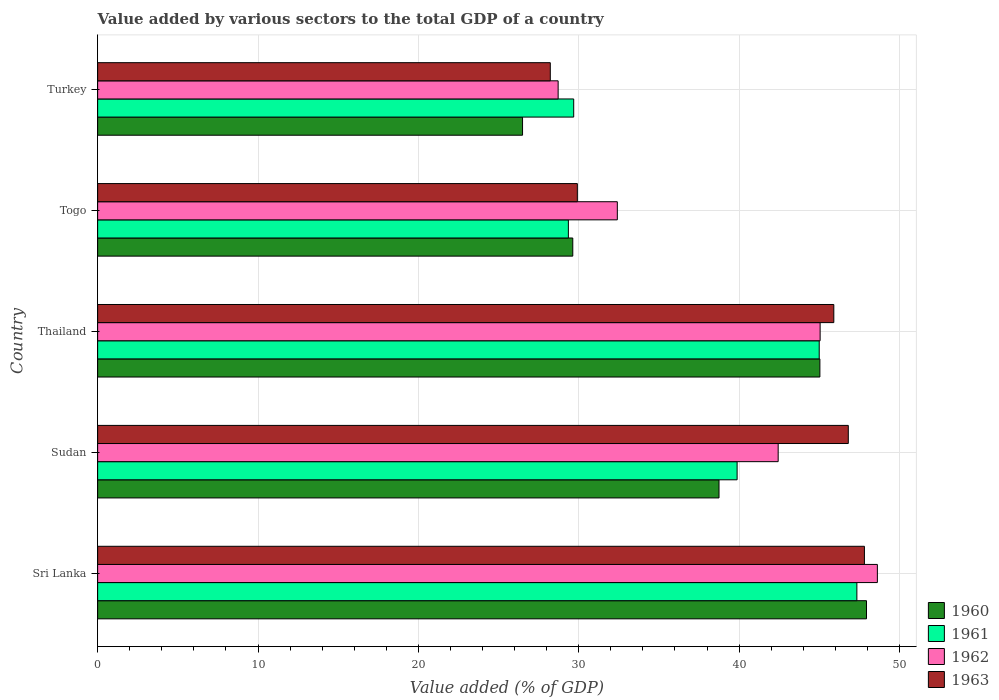Are the number of bars per tick equal to the number of legend labels?
Your answer should be very brief. Yes. Are the number of bars on each tick of the Y-axis equal?
Your answer should be compact. Yes. How many bars are there on the 3rd tick from the bottom?
Your answer should be very brief. 4. What is the label of the 3rd group of bars from the top?
Offer a very short reply. Thailand. In how many cases, is the number of bars for a given country not equal to the number of legend labels?
Ensure brevity in your answer.  0. What is the value added by various sectors to the total GDP in 1960 in Turkey?
Offer a very short reply. 26.5. Across all countries, what is the maximum value added by various sectors to the total GDP in 1960?
Your answer should be very brief. 47.95. Across all countries, what is the minimum value added by various sectors to the total GDP in 1962?
Ensure brevity in your answer.  28.72. In which country was the value added by various sectors to the total GDP in 1963 maximum?
Your answer should be compact. Sri Lanka. What is the total value added by various sectors to the total GDP in 1963 in the graph?
Offer a very short reply. 198.68. What is the difference between the value added by various sectors to the total GDP in 1963 in Sudan and that in Thailand?
Ensure brevity in your answer.  0.9. What is the difference between the value added by various sectors to the total GDP in 1963 in Sudan and the value added by various sectors to the total GDP in 1962 in Thailand?
Offer a very short reply. 1.76. What is the average value added by various sectors to the total GDP in 1962 per country?
Your answer should be very brief. 39.45. What is the difference between the value added by various sectors to the total GDP in 1962 and value added by various sectors to the total GDP in 1961 in Turkey?
Provide a succinct answer. -0.97. In how many countries, is the value added by various sectors to the total GDP in 1962 greater than 10 %?
Make the answer very short. 5. What is the ratio of the value added by various sectors to the total GDP in 1963 in Sudan to that in Thailand?
Provide a succinct answer. 1.02. Is the value added by various sectors to the total GDP in 1962 in Sri Lanka less than that in Thailand?
Make the answer very short. No. Is the difference between the value added by various sectors to the total GDP in 1962 in Thailand and Togo greater than the difference between the value added by various sectors to the total GDP in 1961 in Thailand and Togo?
Provide a short and direct response. No. What is the difference between the highest and the second highest value added by various sectors to the total GDP in 1961?
Provide a succinct answer. 2.35. What is the difference between the highest and the lowest value added by various sectors to the total GDP in 1960?
Offer a very short reply. 21.45. Is the sum of the value added by various sectors to the total GDP in 1963 in Sudan and Turkey greater than the maximum value added by various sectors to the total GDP in 1960 across all countries?
Provide a succinct answer. Yes. Is it the case that in every country, the sum of the value added by various sectors to the total GDP in 1961 and value added by various sectors to the total GDP in 1960 is greater than the sum of value added by various sectors to the total GDP in 1963 and value added by various sectors to the total GDP in 1962?
Provide a short and direct response. No. What does the 3rd bar from the top in Sudan represents?
Provide a short and direct response. 1961. What does the 2nd bar from the bottom in Sri Lanka represents?
Offer a terse response. 1961. Is it the case that in every country, the sum of the value added by various sectors to the total GDP in 1960 and value added by various sectors to the total GDP in 1963 is greater than the value added by various sectors to the total GDP in 1962?
Provide a short and direct response. Yes. Are the values on the major ticks of X-axis written in scientific E-notation?
Your response must be concise. No. Does the graph contain grids?
Provide a short and direct response. Yes. What is the title of the graph?
Give a very brief answer. Value added by various sectors to the total GDP of a country. What is the label or title of the X-axis?
Provide a succinct answer. Value added (% of GDP). What is the label or title of the Y-axis?
Offer a very short reply. Country. What is the Value added (% of GDP) in 1960 in Sri Lanka?
Make the answer very short. 47.95. What is the Value added (% of GDP) of 1961 in Sri Lanka?
Provide a succinct answer. 47.35. What is the Value added (% of GDP) of 1962 in Sri Lanka?
Offer a very short reply. 48.62. What is the Value added (% of GDP) in 1963 in Sri Lanka?
Offer a very short reply. 47.82. What is the Value added (% of GDP) in 1960 in Sudan?
Give a very brief answer. 38.75. What is the Value added (% of GDP) of 1961 in Sudan?
Make the answer very short. 39.88. What is the Value added (% of GDP) of 1962 in Sudan?
Offer a very short reply. 42.44. What is the Value added (% of GDP) in 1963 in Sudan?
Make the answer very short. 46.81. What is the Value added (% of GDP) in 1960 in Thailand?
Offer a very short reply. 45.04. What is the Value added (% of GDP) of 1961 in Thailand?
Offer a very short reply. 45. What is the Value added (% of GDP) in 1962 in Thailand?
Provide a short and direct response. 45.05. What is the Value added (% of GDP) in 1963 in Thailand?
Make the answer very short. 45.91. What is the Value added (% of GDP) of 1960 in Togo?
Make the answer very short. 29.63. What is the Value added (% of GDP) of 1961 in Togo?
Give a very brief answer. 29.35. What is the Value added (% of GDP) of 1962 in Togo?
Make the answer very short. 32.41. What is the Value added (% of GDP) of 1963 in Togo?
Your answer should be very brief. 29.91. What is the Value added (% of GDP) in 1960 in Turkey?
Your answer should be compact. 26.5. What is the Value added (% of GDP) of 1961 in Turkey?
Provide a short and direct response. 29.69. What is the Value added (% of GDP) in 1962 in Turkey?
Give a very brief answer. 28.72. What is the Value added (% of GDP) of 1963 in Turkey?
Make the answer very short. 28.23. Across all countries, what is the maximum Value added (% of GDP) of 1960?
Provide a short and direct response. 47.95. Across all countries, what is the maximum Value added (% of GDP) in 1961?
Offer a very short reply. 47.35. Across all countries, what is the maximum Value added (% of GDP) in 1962?
Make the answer very short. 48.62. Across all countries, what is the maximum Value added (% of GDP) in 1963?
Give a very brief answer. 47.82. Across all countries, what is the minimum Value added (% of GDP) in 1960?
Ensure brevity in your answer.  26.5. Across all countries, what is the minimum Value added (% of GDP) in 1961?
Ensure brevity in your answer.  29.35. Across all countries, what is the minimum Value added (% of GDP) in 1962?
Your response must be concise. 28.72. Across all countries, what is the minimum Value added (% of GDP) in 1963?
Your answer should be very brief. 28.23. What is the total Value added (% of GDP) of 1960 in the graph?
Make the answer very short. 187.86. What is the total Value added (% of GDP) of 1961 in the graph?
Your answer should be compact. 191.26. What is the total Value added (% of GDP) in 1962 in the graph?
Offer a very short reply. 197.24. What is the total Value added (% of GDP) in 1963 in the graph?
Give a very brief answer. 198.68. What is the difference between the Value added (% of GDP) in 1960 in Sri Lanka and that in Sudan?
Provide a short and direct response. 9.2. What is the difference between the Value added (% of GDP) in 1961 in Sri Lanka and that in Sudan?
Your response must be concise. 7.47. What is the difference between the Value added (% of GDP) of 1962 in Sri Lanka and that in Sudan?
Make the answer very short. 6.19. What is the difference between the Value added (% of GDP) in 1960 in Sri Lanka and that in Thailand?
Give a very brief answer. 2.91. What is the difference between the Value added (% of GDP) in 1961 in Sri Lanka and that in Thailand?
Offer a terse response. 2.35. What is the difference between the Value added (% of GDP) of 1962 in Sri Lanka and that in Thailand?
Make the answer very short. 3.57. What is the difference between the Value added (% of GDP) in 1963 in Sri Lanka and that in Thailand?
Make the answer very short. 1.91. What is the difference between the Value added (% of GDP) of 1960 in Sri Lanka and that in Togo?
Your answer should be compact. 18.32. What is the difference between the Value added (% of GDP) of 1961 in Sri Lanka and that in Togo?
Ensure brevity in your answer.  17.99. What is the difference between the Value added (% of GDP) in 1962 in Sri Lanka and that in Togo?
Your response must be concise. 16.22. What is the difference between the Value added (% of GDP) in 1963 in Sri Lanka and that in Togo?
Offer a terse response. 17.9. What is the difference between the Value added (% of GDP) in 1960 in Sri Lanka and that in Turkey?
Make the answer very short. 21.45. What is the difference between the Value added (% of GDP) in 1961 in Sri Lanka and that in Turkey?
Offer a very short reply. 17.66. What is the difference between the Value added (% of GDP) of 1962 in Sri Lanka and that in Turkey?
Your answer should be compact. 19.91. What is the difference between the Value added (% of GDP) in 1963 in Sri Lanka and that in Turkey?
Your response must be concise. 19.59. What is the difference between the Value added (% of GDP) in 1960 in Sudan and that in Thailand?
Provide a succinct answer. -6.29. What is the difference between the Value added (% of GDP) of 1961 in Sudan and that in Thailand?
Your response must be concise. -5.12. What is the difference between the Value added (% of GDP) in 1962 in Sudan and that in Thailand?
Give a very brief answer. -2.62. What is the difference between the Value added (% of GDP) of 1963 in Sudan and that in Thailand?
Offer a very short reply. 0.9. What is the difference between the Value added (% of GDP) of 1960 in Sudan and that in Togo?
Your answer should be compact. 9.12. What is the difference between the Value added (% of GDP) of 1961 in Sudan and that in Togo?
Offer a terse response. 10.52. What is the difference between the Value added (% of GDP) in 1962 in Sudan and that in Togo?
Make the answer very short. 10.03. What is the difference between the Value added (% of GDP) of 1963 in Sudan and that in Togo?
Your answer should be compact. 16.9. What is the difference between the Value added (% of GDP) of 1960 in Sudan and that in Turkey?
Your response must be concise. 12.25. What is the difference between the Value added (% of GDP) of 1961 in Sudan and that in Turkey?
Your response must be concise. 10.19. What is the difference between the Value added (% of GDP) in 1962 in Sudan and that in Turkey?
Offer a terse response. 13.72. What is the difference between the Value added (% of GDP) of 1963 in Sudan and that in Turkey?
Make the answer very short. 18.58. What is the difference between the Value added (% of GDP) of 1960 in Thailand and that in Togo?
Ensure brevity in your answer.  15.41. What is the difference between the Value added (% of GDP) of 1961 in Thailand and that in Togo?
Make the answer very short. 15.64. What is the difference between the Value added (% of GDP) in 1962 in Thailand and that in Togo?
Your response must be concise. 12.65. What is the difference between the Value added (% of GDP) in 1963 in Thailand and that in Togo?
Keep it short and to the point. 15.99. What is the difference between the Value added (% of GDP) of 1960 in Thailand and that in Turkey?
Offer a terse response. 18.54. What is the difference between the Value added (% of GDP) of 1961 in Thailand and that in Turkey?
Make the answer very short. 15.31. What is the difference between the Value added (% of GDP) in 1962 in Thailand and that in Turkey?
Your answer should be very brief. 16.34. What is the difference between the Value added (% of GDP) in 1963 in Thailand and that in Turkey?
Your answer should be compact. 17.68. What is the difference between the Value added (% of GDP) in 1960 in Togo and that in Turkey?
Your answer should be compact. 3.13. What is the difference between the Value added (% of GDP) of 1961 in Togo and that in Turkey?
Make the answer very short. -0.33. What is the difference between the Value added (% of GDP) in 1962 in Togo and that in Turkey?
Your answer should be very brief. 3.69. What is the difference between the Value added (% of GDP) in 1963 in Togo and that in Turkey?
Provide a succinct answer. 1.69. What is the difference between the Value added (% of GDP) of 1960 in Sri Lanka and the Value added (% of GDP) of 1961 in Sudan?
Offer a terse response. 8.07. What is the difference between the Value added (% of GDP) of 1960 in Sri Lanka and the Value added (% of GDP) of 1962 in Sudan?
Give a very brief answer. 5.51. What is the difference between the Value added (% of GDP) in 1960 in Sri Lanka and the Value added (% of GDP) in 1963 in Sudan?
Your answer should be very brief. 1.14. What is the difference between the Value added (% of GDP) in 1961 in Sri Lanka and the Value added (% of GDP) in 1962 in Sudan?
Your response must be concise. 4.91. What is the difference between the Value added (% of GDP) of 1961 in Sri Lanka and the Value added (% of GDP) of 1963 in Sudan?
Your response must be concise. 0.53. What is the difference between the Value added (% of GDP) of 1962 in Sri Lanka and the Value added (% of GDP) of 1963 in Sudan?
Offer a very short reply. 1.81. What is the difference between the Value added (% of GDP) of 1960 in Sri Lanka and the Value added (% of GDP) of 1961 in Thailand?
Provide a succinct answer. 2.95. What is the difference between the Value added (% of GDP) of 1960 in Sri Lanka and the Value added (% of GDP) of 1962 in Thailand?
Provide a succinct answer. 2.89. What is the difference between the Value added (% of GDP) of 1960 in Sri Lanka and the Value added (% of GDP) of 1963 in Thailand?
Your answer should be very brief. 2.04. What is the difference between the Value added (% of GDP) of 1961 in Sri Lanka and the Value added (% of GDP) of 1962 in Thailand?
Provide a succinct answer. 2.29. What is the difference between the Value added (% of GDP) of 1961 in Sri Lanka and the Value added (% of GDP) of 1963 in Thailand?
Ensure brevity in your answer.  1.44. What is the difference between the Value added (% of GDP) in 1962 in Sri Lanka and the Value added (% of GDP) in 1963 in Thailand?
Your answer should be very brief. 2.72. What is the difference between the Value added (% of GDP) of 1960 in Sri Lanka and the Value added (% of GDP) of 1961 in Togo?
Offer a terse response. 18.59. What is the difference between the Value added (% of GDP) of 1960 in Sri Lanka and the Value added (% of GDP) of 1962 in Togo?
Offer a very short reply. 15.54. What is the difference between the Value added (% of GDP) of 1960 in Sri Lanka and the Value added (% of GDP) of 1963 in Togo?
Ensure brevity in your answer.  18.03. What is the difference between the Value added (% of GDP) in 1961 in Sri Lanka and the Value added (% of GDP) in 1962 in Togo?
Provide a succinct answer. 14.94. What is the difference between the Value added (% of GDP) of 1961 in Sri Lanka and the Value added (% of GDP) of 1963 in Togo?
Give a very brief answer. 17.43. What is the difference between the Value added (% of GDP) of 1962 in Sri Lanka and the Value added (% of GDP) of 1963 in Togo?
Make the answer very short. 18.71. What is the difference between the Value added (% of GDP) of 1960 in Sri Lanka and the Value added (% of GDP) of 1961 in Turkey?
Your response must be concise. 18.26. What is the difference between the Value added (% of GDP) of 1960 in Sri Lanka and the Value added (% of GDP) of 1962 in Turkey?
Your answer should be compact. 19.23. What is the difference between the Value added (% of GDP) in 1960 in Sri Lanka and the Value added (% of GDP) in 1963 in Turkey?
Ensure brevity in your answer.  19.72. What is the difference between the Value added (% of GDP) in 1961 in Sri Lanka and the Value added (% of GDP) in 1962 in Turkey?
Offer a terse response. 18.63. What is the difference between the Value added (% of GDP) of 1961 in Sri Lanka and the Value added (% of GDP) of 1963 in Turkey?
Give a very brief answer. 19.12. What is the difference between the Value added (% of GDP) in 1962 in Sri Lanka and the Value added (% of GDP) in 1963 in Turkey?
Offer a terse response. 20.4. What is the difference between the Value added (% of GDP) of 1960 in Sudan and the Value added (% of GDP) of 1961 in Thailand?
Your answer should be very brief. -6.25. What is the difference between the Value added (% of GDP) of 1960 in Sudan and the Value added (% of GDP) of 1962 in Thailand?
Give a very brief answer. -6.31. What is the difference between the Value added (% of GDP) in 1960 in Sudan and the Value added (% of GDP) in 1963 in Thailand?
Offer a terse response. -7.16. What is the difference between the Value added (% of GDP) of 1961 in Sudan and the Value added (% of GDP) of 1962 in Thailand?
Offer a terse response. -5.18. What is the difference between the Value added (% of GDP) in 1961 in Sudan and the Value added (% of GDP) in 1963 in Thailand?
Offer a very short reply. -6.03. What is the difference between the Value added (% of GDP) of 1962 in Sudan and the Value added (% of GDP) of 1963 in Thailand?
Your answer should be compact. -3.47. What is the difference between the Value added (% of GDP) in 1960 in Sudan and the Value added (% of GDP) in 1961 in Togo?
Give a very brief answer. 9.39. What is the difference between the Value added (% of GDP) of 1960 in Sudan and the Value added (% of GDP) of 1962 in Togo?
Provide a succinct answer. 6.34. What is the difference between the Value added (% of GDP) of 1960 in Sudan and the Value added (% of GDP) of 1963 in Togo?
Make the answer very short. 8.83. What is the difference between the Value added (% of GDP) in 1961 in Sudan and the Value added (% of GDP) in 1962 in Togo?
Give a very brief answer. 7.47. What is the difference between the Value added (% of GDP) in 1961 in Sudan and the Value added (% of GDP) in 1963 in Togo?
Ensure brevity in your answer.  9.96. What is the difference between the Value added (% of GDP) in 1962 in Sudan and the Value added (% of GDP) in 1963 in Togo?
Give a very brief answer. 12.52. What is the difference between the Value added (% of GDP) of 1960 in Sudan and the Value added (% of GDP) of 1961 in Turkey?
Your answer should be very brief. 9.06. What is the difference between the Value added (% of GDP) of 1960 in Sudan and the Value added (% of GDP) of 1962 in Turkey?
Your response must be concise. 10.03. What is the difference between the Value added (% of GDP) of 1960 in Sudan and the Value added (% of GDP) of 1963 in Turkey?
Keep it short and to the point. 10.52. What is the difference between the Value added (% of GDP) in 1961 in Sudan and the Value added (% of GDP) in 1962 in Turkey?
Provide a succinct answer. 11.16. What is the difference between the Value added (% of GDP) of 1961 in Sudan and the Value added (% of GDP) of 1963 in Turkey?
Offer a terse response. 11.65. What is the difference between the Value added (% of GDP) in 1962 in Sudan and the Value added (% of GDP) in 1963 in Turkey?
Offer a terse response. 14.21. What is the difference between the Value added (% of GDP) in 1960 in Thailand and the Value added (% of GDP) in 1961 in Togo?
Provide a succinct answer. 15.68. What is the difference between the Value added (% of GDP) of 1960 in Thailand and the Value added (% of GDP) of 1962 in Togo?
Offer a terse response. 12.63. What is the difference between the Value added (% of GDP) of 1960 in Thailand and the Value added (% of GDP) of 1963 in Togo?
Ensure brevity in your answer.  15.12. What is the difference between the Value added (% of GDP) of 1961 in Thailand and the Value added (% of GDP) of 1962 in Togo?
Your answer should be very brief. 12.59. What is the difference between the Value added (% of GDP) in 1961 in Thailand and the Value added (% of GDP) in 1963 in Togo?
Give a very brief answer. 15.08. What is the difference between the Value added (% of GDP) in 1962 in Thailand and the Value added (% of GDP) in 1963 in Togo?
Your answer should be very brief. 15.14. What is the difference between the Value added (% of GDP) of 1960 in Thailand and the Value added (% of GDP) of 1961 in Turkey?
Your answer should be compact. 15.35. What is the difference between the Value added (% of GDP) of 1960 in Thailand and the Value added (% of GDP) of 1962 in Turkey?
Keep it short and to the point. 16.32. What is the difference between the Value added (% of GDP) of 1960 in Thailand and the Value added (% of GDP) of 1963 in Turkey?
Ensure brevity in your answer.  16.81. What is the difference between the Value added (% of GDP) of 1961 in Thailand and the Value added (% of GDP) of 1962 in Turkey?
Your response must be concise. 16.28. What is the difference between the Value added (% of GDP) in 1961 in Thailand and the Value added (% of GDP) in 1963 in Turkey?
Make the answer very short. 16.77. What is the difference between the Value added (% of GDP) of 1962 in Thailand and the Value added (% of GDP) of 1963 in Turkey?
Provide a succinct answer. 16.83. What is the difference between the Value added (% of GDP) of 1960 in Togo and the Value added (% of GDP) of 1961 in Turkey?
Your answer should be compact. -0.06. What is the difference between the Value added (% of GDP) of 1960 in Togo and the Value added (% of GDP) of 1962 in Turkey?
Offer a very short reply. 0.91. What is the difference between the Value added (% of GDP) in 1960 in Togo and the Value added (% of GDP) in 1963 in Turkey?
Ensure brevity in your answer.  1.4. What is the difference between the Value added (% of GDP) in 1961 in Togo and the Value added (% of GDP) in 1962 in Turkey?
Provide a short and direct response. 0.64. What is the difference between the Value added (% of GDP) in 1961 in Togo and the Value added (% of GDP) in 1963 in Turkey?
Provide a succinct answer. 1.13. What is the difference between the Value added (% of GDP) in 1962 in Togo and the Value added (% of GDP) in 1963 in Turkey?
Keep it short and to the point. 4.18. What is the average Value added (% of GDP) of 1960 per country?
Ensure brevity in your answer.  37.57. What is the average Value added (% of GDP) in 1961 per country?
Your answer should be very brief. 38.25. What is the average Value added (% of GDP) of 1962 per country?
Your response must be concise. 39.45. What is the average Value added (% of GDP) of 1963 per country?
Your response must be concise. 39.74. What is the difference between the Value added (% of GDP) of 1960 and Value added (% of GDP) of 1961 in Sri Lanka?
Your answer should be very brief. 0.6. What is the difference between the Value added (% of GDP) in 1960 and Value added (% of GDP) in 1962 in Sri Lanka?
Your response must be concise. -0.68. What is the difference between the Value added (% of GDP) in 1960 and Value added (% of GDP) in 1963 in Sri Lanka?
Ensure brevity in your answer.  0.13. What is the difference between the Value added (% of GDP) in 1961 and Value added (% of GDP) in 1962 in Sri Lanka?
Your answer should be very brief. -1.28. What is the difference between the Value added (% of GDP) in 1961 and Value added (% of GDP) in 1963 in Sri Lanka?
Your answer should be compact. -0.47. What is the difference between the Value added (% of GDP) in 1962 and Value added (% of GDP) in 1963 in Sri Lanka?
Your answer should be compact. 0.81. What is the difference between the Value added (% of GDP) in 1960 and Value added (% of GDP) in 1961 in Sudan?
Provide a short and direct response. -1.13. What is the difference between the Value added (% of GDP) of 1960 and Value added (% of GDP) of 1962 in Sudan?
Offer a very short reply. -3.69. What is the difference between the Value added (% of GDP) in 1960 and Value added (% of GDP) in 1963 in Sudan?
Your answer should be compact. -8.06. What is the difference between the Value added (% of GDP) in 1961 and Value added (% of GDP) in 1962 in Sudan?
Provide a succinct answer. -2.56. What is the difference between the Value added (% of GDP) in 1961 and Value added (% of GDP) in 1963 in Sudan?
Provide a succinct answer. -6.93. What is the difference between the Value added (% of GDP) of 1962 and Value added (% of GDP) of 1963 in Sudan?
Your answer should be very brief. -4.37. What is the difference between the Value added (% of GDP) in 1960 and Value added (% of GDP) in 1961 in Thailand?
Your response must be concise. 0.04. What is the difference between the Value added (% of GDP) of 1960 and Value added (% of GDP) of 1962 in Thailand?
Offer a very short reply. -0.02. What is the difference between the Value added (% of GDP) of 1960 and Value added (% of GDP) of 1963 in Thailand?
Make the answer very short. -0.87. What is the difference between the Value added (% of GDP) of 1961 and Value added (% of GDP) of 1962 in Thailand?
Provide a short and direct response. -0.06. What is the difference between the Value added (% of GDP) of 1961 and Value added (% of GDP) of 1963 in Thailand?
Your answer should be compact. -0.91. What is the difference between the Value added (% of GDP) in 1962 and Value added (% of GDP) in 1963 in Thailand?
Your response must be concise. -0.85. What is the difference between the Value added (% of GDP) of 1960 and Value added (% of GDP) of 1961 in Togo?
Give a very brief answer. 0.27. What is the difference between the Value added (% of GDP) in 1960 and Value added (% of GDP) in 1962 in Togo?
Give a very brief answer. -2.78. What is the difference between the Value added (% of GDP) of 1960 and Value added (% of GDP) of 1963 in Togo?
Offer a terse response. -0.28. What is the difference between the Value added (% of GDP) in 1961 and Value added (% of GDP) in 1962 in Togo?
Keep it short and to the point. -3.05. What is the difference between the Value added (% of GDP) in 1961 and Value added (% of GDP) in 1963 in Togo?
Offer a very short reply. -0.56. What is the difference between the Value added (% of GDP) of 1962 and Value added (% of GDP) of 1963 in Togo?
Provide a succinct answer. 2.49. What is the difference between the Value added (% of GDP) of 1960 and Value added (% of GDP) of 1961 in Turkey?
Your response must be concise. -3.19. What is the difference between the Value added (% of GDP) in 1960 and Value added (% of GDP) in 1962 in Turkey?
Your answer should be very brief. -2.22. What is the difference between the Value added (% of GDP) of 1960 and Value added (% of GDP) of 1963 in Turkey?
Give a very brief answer. -1.73. What is the difference between the Value added (% of GDP) in 1961 and Value added (% of GDP) in 1962 in Turkey?
Your answer should be compact. 0.97. What is the difference between the Value added (% of GDP) in 1961 and Value added (% of GDP) in 1963 in Turkey?
Give a very brief answer. 1.46. What is the difference between the Value added (% of GDP) of 1962 and Value added (% of GDP) of 1963 in Turkey?
Give a very brief answer. 0.49. What is the ratio of the Value added (% of GDP) of 1960 in Sri Lanka to that in Sudan?
Provide a short and direct response. 1.24. What is the ratio of the Value added (% of GDP) of 1961 in Sri Lanka to that in Sudan?
Provide a short and direct response. 1.19. What is the ratio of the Value added (% of GDP) of 1962 in Sri Lanka to that in Sudan?
Keep it short and to the point. 1.15. What is the ratio of the Value added (% of GDP) in 1963 in Sri Lanka to that in Sudan?
Your response must be concise. 1.02. What is the ratio of the Value added (% of GDP) of 1960 in Sri Lanka to that in Thailand?
Offer a terse response. 1.06. What is the ratio of the Value added (% of GDP) of 1961 in Sri Lanka to that in Thailand?
Ensure brevity in your answer.  1.05. What is the ratio of the Value added (% of GDP) in 1962 in Sri Lanka to that in Thailand?
Keep it short and to the point. 1.08. What is the ratio of the Value added (% of GDP) of 1963 in Sri Lanka to that in Thailand?
Your response must be concise. 1.04. What is the ratio of the Value added (% of GDP) of 1960 in Sri Lanka to that in Togo?
Keep it short and to the point. 1.62. What is the ratio of the Value added (% of GDP) in 1961 in Sri Lanka to that in Togo?
Keep it short and to the point. 1.61. What is the ratio of the Value added (% of GDP) of 1962 in Sri Lanka to that in Togo?
Offer a very short reply. 1.5. What is the ratio of the Value added (% of GDP) of 1963 in Sri Lanka to that in Togo?
Keep it short and to the point. 1.6. What is the ratio of the Value added (% of GDP) in 1960 in Sri Lanka to that in Turkey?
Ensure brevity in your answer.  1.81. What is the ratio of the Value added (% of GDP) of 1961 in Sri Lanka to that in Turkey?
Ensure brevity in your answer.  1.59. What is the ratio of the Value added (% of GDP) in 1962 in Sri Lanka to that in Turkey?
Provide a short and direct response. 1.69. What is the ratio of the Value added (% of GDP) in 1963 in Sri Lanka to that in Turkey?
Offer a terse response. 1.69. What is the ratio of the Value added (% of GDP) in 1960 in Sudan to that in Thailand?
Provide a succinct answer. 0.86. What is the ratio of the Value added (% of GDP) in 1961 in Sudan to that in Thailand?
Offer a terse response. 0.89. What is the ratio of the Value added (% of GDP) of 1962 in Sudan to that in Thailand?
Your response must be concise. 0.94. What is the ratio of the Value added (% of GDP) of 1963 in Sudan to that in Thailand?
Keep it short and to the point. 1.02. What is the ratio of the Value added (% of GDP) in 1960 in Sudan to that in Togo?
Ensure brevity in your answer.  1.31. What is the ratio of the Value added (% of GDP) of 1961 in Sudan to that in Togo?
Keep it short and to the point. 1.36. What is the ratio of the Value added (% of GDP) of 1962 in Sudan to that in Togo?
Your answer should be compact. 1.31. What is the ratio of the Value added (% of GDP) in 1963 in Sudan to that in Togo?
Your answer should be very brief. 1.56. What is the ratio of the Value added (% of GDP) of 1960 in Sudan to that in Turkey?
Your answer should be very brief. 1.46. What is the ratio of the Value added (% of GDP) in 1961 in Sudan to that in Turkey?
Provide a succinct answer. 1.34. What is the ratio of the Value added (% of GDP) of 1962 in Sudan to that in Turkey?
Make the answer very short. 1.48. What is the ratio of the Value added (% of GDP) in 1963 in Sudan to that in Turkey?
Offer a very short reply. 1.66. What is the ratio of the Value added (% of GDP) of 1960 in Thailand to that in Togo?
Offer a terse response. 1.52. What is the ratio of the Value added (% of GDP) of 1961 in Thailand to that in Togo?
Offer a terse response. 1.53. What is the ratio of the Value added (% of GDP) in 1962 in Thailand to that in Togo?
Make the answer very short. 1.39. What is the ratio of the Value added (% of GDP) in 1963 in Thailand to that in Togo?
Provide a short and direct response. 1.53. What is the ratio of the Value added (% of GDP) of 1960 in Thailand to that in Turkey?
Give a very brief answer. 1.7. What is the ratio of the Value added (% of GDP) of 1961 in Thailand to that in Turkey?
Give a very brief answer. 1.52. What is the ratio of the Value added (% of GDP) of 1962 in Thailand to that in Turkey?
Provide a succinct answer. 1.57. What is the ratio of the Value added (% of GDP) of 1963 in Thailand to that in Turkey?
Make the answer very short. 1.63. What is the ratio of the Value added (% of GDP) in 1960 in Togo to that in Turkey?
Provide a succinct answer. 1.12. What is the ratio of the Value added (% of GDP) of 1961 in Togo to that in Turkey?
Ensure brevity in your answer.  0.99. What is the ratio of the Value added (% of GDP) of 1962 in Togo to that in Turkey?
Give a very brief answer. 1.13. What is the ratio of the Value added (% of GDP) in 1963 in Togo to that in Turkey?
Provide a succinct answer. 1.06. What is the difference between the highest and the second highest Value added (% of GDP) in 1960?
Offer a terse response. 2.91. What is the difference between the highest and the second highest Value added (% of GDP) in 1961?
Keep it short and to the point. 2.35. What is the difference between the highest and the second highest Value added (% of GDP) of 1962?
Your response must be concise. 3.57. What is the difference between the highest and the second highest Value added (% of GDP) in 1963?
Make the answer very short. 1.01. What is the difference between the highest and the lowest Value added (% of GDP) of 1960?
Your answer should be compact. 21.45. What is the difference between the highest and the lowest Value added (% of GDP) of 1961?
Make the answer very short. 17.99. What is the difference between the highest and the lowest Value added (% of GDP) of 1962?
Give a very brief answer. 19.91. What is the difference between the highest and the lowest Value added (% of GDP) of 1963?
Ensure brevity in your answer.  19.59. 